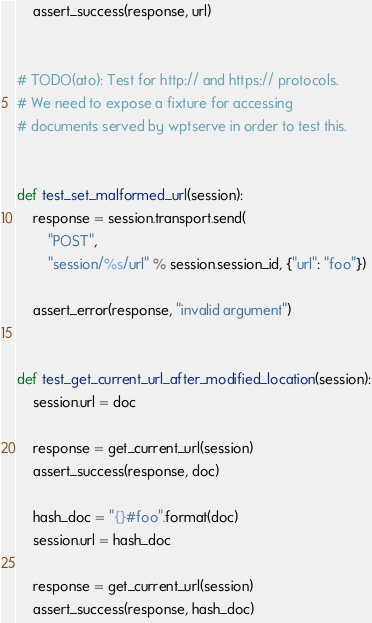Convert code to text. <code><loc_0><loc_0><loc_500><loc_500><_Python_>    assert_success(response, url)


# TODO(ato): Test for http:// and https:// protocols.
# We need to expose a fixture for accessing
# documents served by wptserve in order to test this.


def test_set_malformed_url(session):
    response = session.transport.send(
        "POST",
        "session/%s/url" % session.session_id, {"url": "foo"})

    assert_error(response, "invalid argument")


def test_get_current_url_after_modified_location(session):
    session.url = doc

    response = get_current_url(session)
    assert_success(response, doc)

    hash_doc = "{}#foo".format(doc)
    session.url = hash_doc

    response = get_current_url(session)
    assert_success(response, hash_doc)
</code> 